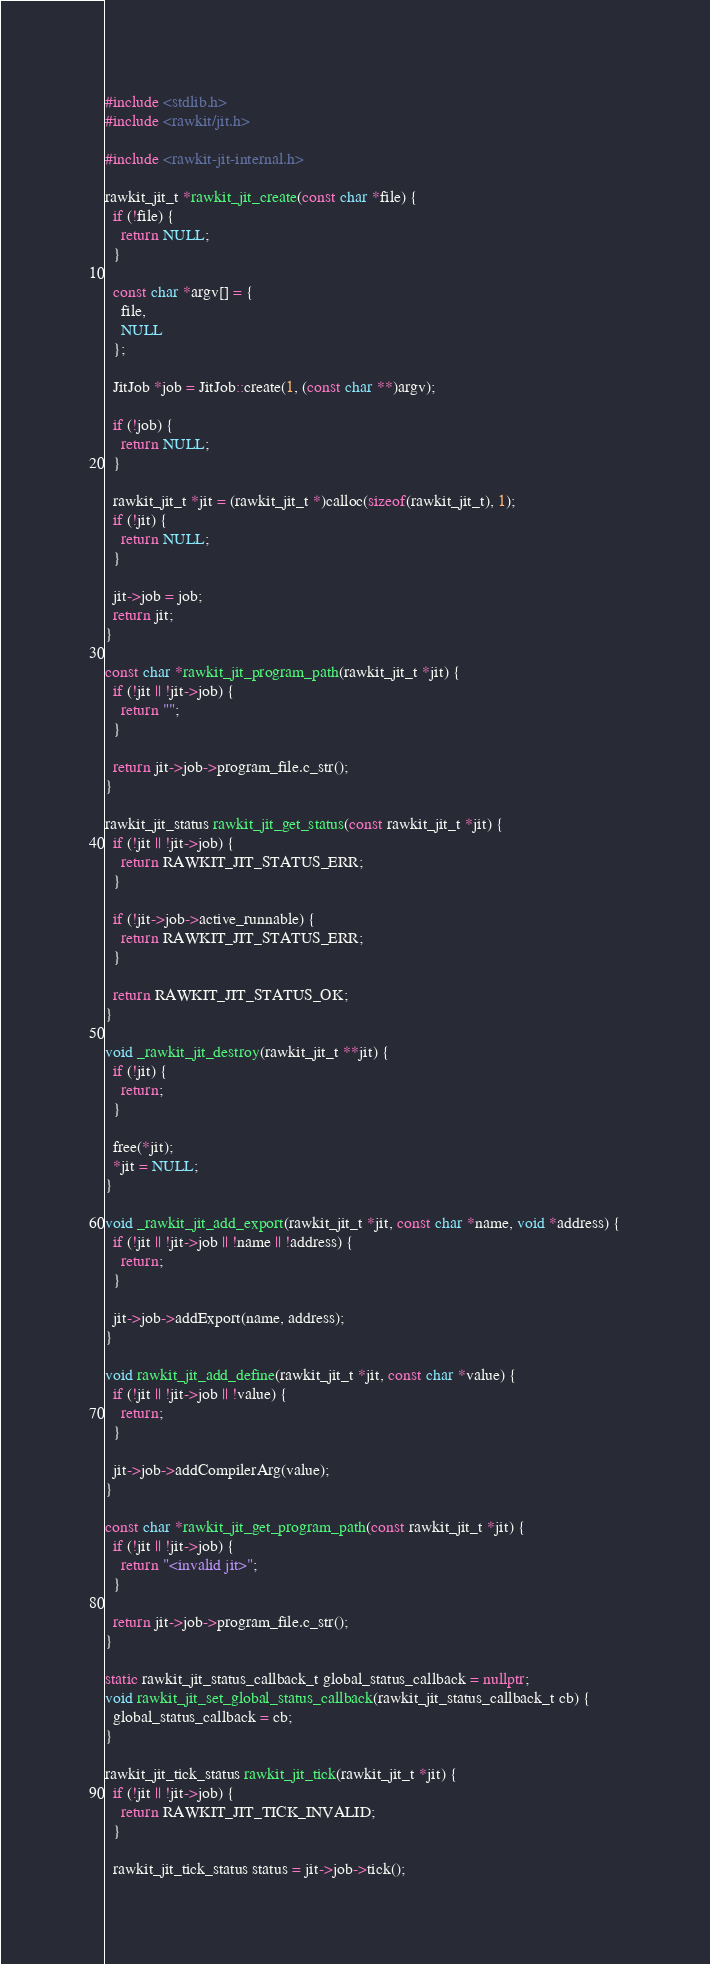<code> <loc_0><loc_0><loc_500><loc_500><_C++_>#include <stdlib.h>
#include <rawkit/jit.h>

#include <rawkit-jit-internal.h>

rawkit_jit_t *rawkit_jit_create(const char *file) {
  if (!file) {
    return NULL;
  }

  const char *argv[] = {
    file,
    NULL
  };

  JitJob *job = JitJob::create(1, (const char **)argv);

  if (!job) {
    return NULL;
  }

  rawkit_jit_t *jit = (rawkit_jit_t *)calloc(sizeof(rawkit_jit_t), 1);
  if (!jit) {
    return NULL;
  }

  jit->job = job;
  return jit;
}

const char *rawkit_jit_program_path(rawkit_jit_t *jit) {
  if (!jit || !jit->job) {
    return "";
  }

  return jit->job->program_file.c_str();
}

rawkit_jit_status rawkit_jit_get_status(const rawkit_jit_t *jit) {
  if (!jit || !jit->job) {
    return RAWKIT_JIT_STATUS_ERR;
  }

  if (!jit->job->active_runnable) {
    return RAWKIT_JIT_STATUS_ERR;
  }

  return RAWKIT_JIT_STATUS_OK;
}

void _rawkit_jit_destroy(rawkit_jit_t **jit) {
  if (!jit) {
    return;
  }

  free(*jit);
  *jit = NULL;
}

void _rawkit_jit_add_export(rawkit_jit_t *jit, const char *name, void *address) {
  if (!jit || !jit->job || !name || !address) {
    return;
  }

  jit->job->addExport(name, address);
}

void rawkit_jit_add_define(rawkit_jit_t *jit, const char *value) {
  if (!jit || !jit->job || !value) {
    return;
  }

  jit->job->addCompilerArg(value);
}

const char *rawkit_jit_get_program_path(const rawkit_jit_t *jit) {
  if (!jit || !jit->job) {
    return "<invalid jit>";
  }

  return jit->job->program_file.c_str();
}

static rawkit_jit_status_callback_t global_status_callback = nullptr;
void rawkit_jit_set_global_status_callback(rawkit_jit_status_callback_t cb) {
  global_status_callback = cb;
}

rawkit_jit_tick_status rawkit_jit_tick(rawkit_jit_t *jit) {
  if (!jit || !jit->job) {
    return RAWKIT_JIT_TICK_INVALID;
  }

  rawkit_jit_tick_status status = jit->job->tick();
</code> 